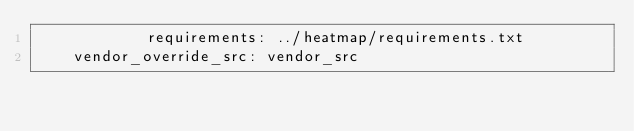Convert code to text. <code><loc_0><loc_0><loc_500><loc_500><_YAML_>            requirements: ../heatmap/requirements.txt
    vendor_override_src: vendor_src
</code> 